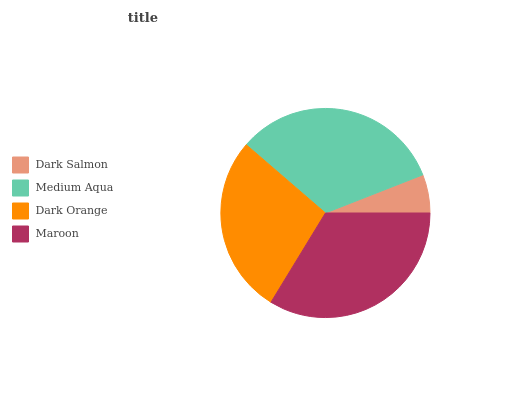Is Dark Salmon the minimum?
Answer yes or no. Yes. Is Maroon the maximum?
Answer yes or no. Yes. Is Medium Aqua the minimum?
Answer yes or no. No. Is Medium Aqua the maximum?
Answer yes or no. No. Is Medium Aqua greater than Dark Salmon?
Answer yes or no. Yes. Is Dark Salmon less than Medium Aqua?
Answer yes or no. Yes. Is Dark Salmon greater than Medium Aqua?
Answer yes or no. No. Is Medium Aqua less than Dark Salmon?
Answer yes or no. No. Is Medium Aqua the high median?
Answer yes or no. Yes. Is Dark Orange the low median?
Answer yes or no. Yes. Is Maroon the high median?
Answer yes or no. No. Is Medium Aqua the low median?
Answer yes or no. No. 